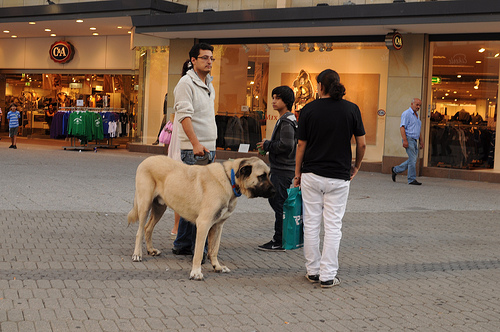What types of activities seem to be happening around the dog in the image? The dog in the image appears to be the center of attention in a social gathering, with people around it likely engaging in casual conversation, enjoying the outdoor setting of a shopping area. 